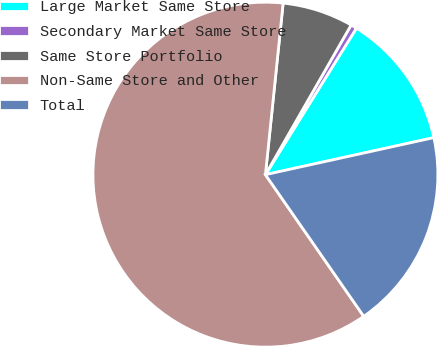Convert chart. <chart><loc_0><loc_0><loc_500><loc_500><pie_chart><fcel>Large Market Same Store<fcel>Secondary Market Same Store<fcel>Same Store Portfolio<fcel>Non-Same Store and Other<fcel>Total<nl><fcel>12.71%<fcel>0.57%<fcel>6.64%<fcel>61.3%<fcel>18.79%<nl></chart> 